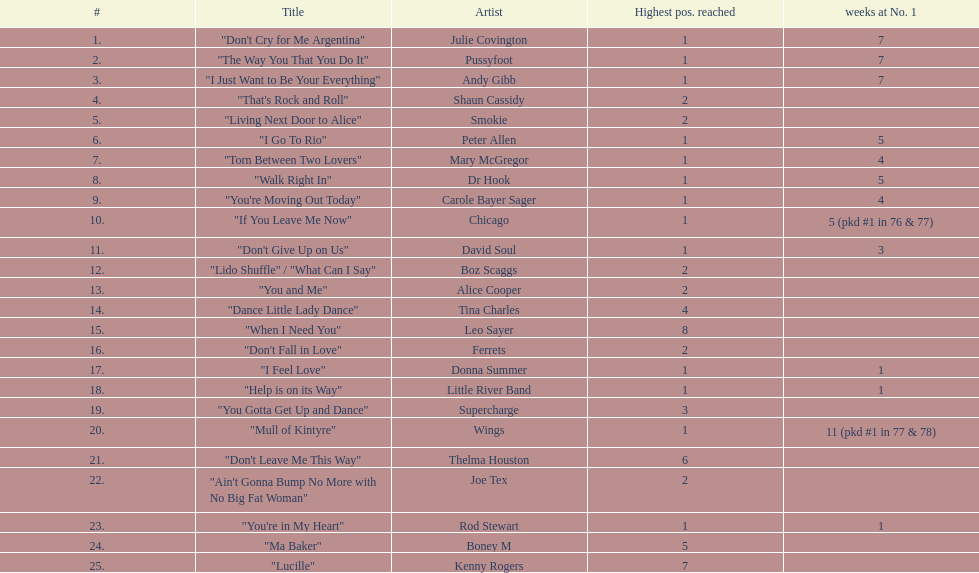How many tunes in the table merely achieved spot number 2? 6. 